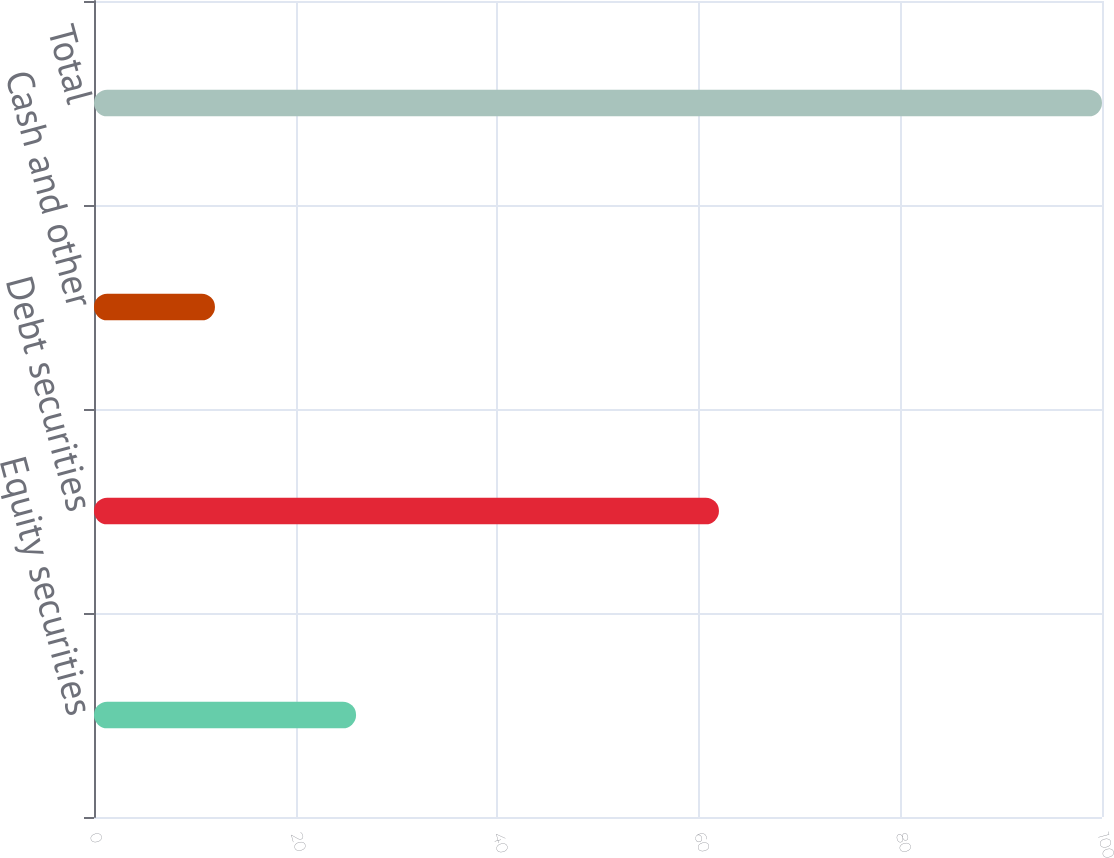<chart> <loc_0><loc_0><loc_500><loc_500><bar_chart><fcel>Equity securities<fcel>Debt securities<fcel>Cash and other<fcel>Total<nl><fcel>26<fcel>62<fcel>12<fcel>100<nl></chart> 